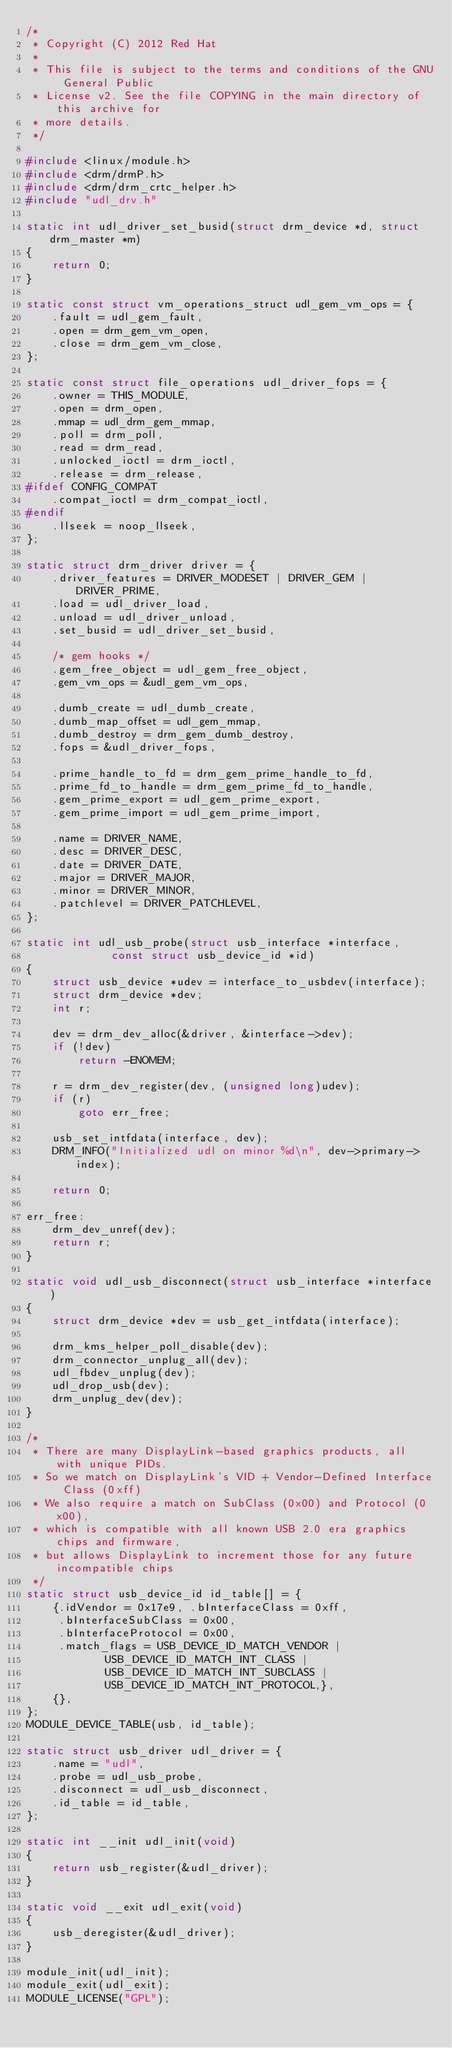<code> <loc_0><loc_0><loc_500><loc_500><_C_>/*
 * Copyright (C) 2012 Red Hat
 *
 * This file is subject to the terms and conditions of the GNU General Public
 * License v2. See the file COPYING in the main directory of this archive for
 * more details.
 */

#include <linux/module.h>
#include <drm/drmP.h>
#include <drm/drm_crtc_helper.h>
#include "udl_drv.h"

static int udl_driver_set_busid(struct drm_device *d, struct drm_master *m)
{
	return 0;
}

static const struct vm_operations_struct udl_gem_vm_ops = {
	.fault = udl_gem_fault,
	.open = drm_gem_vm_open,
	.close = drm_gem_vm_close,
};

static const struct file_operations udl_driver_fops = {
	.owner = THIS_MODULE,
	.open = drm_open,
	.mmap = udl_drm_gem_mmap,
	.poll = drm_poll,
	.read = drm_read,
	.unlocked_ioctl	= drm_ioctl,
	.release = drm_release,
#ifdef CONFIG_COMPAT
	.compat_ioctl = drm_compat_ioctl,
#endif
	.llseek = noop_llseek,
};

static struct drm_driver driver = {
	.driver_features = DRIVER_MODESET | DRIVER_GEM | DRIVER_PRIME,
	.load = udl_driver_load,
	.unload = udl_driver_unload,
	.set_busid = udl_driver_set_busid,

	/* gem hooks */
	.gem_free_object = udl_gem_free_object,
	.gem_vm_ops = &udl_gem_vm_ops,

	.dumb_create = udl_dumb_create,
	.dumb_map_offset = udl_gem_mmap,
	.dumb_destroy = drm_gem_dumb_destroy,
	.fops = &udl_driver_fops,

	.prime_handle_to_fd = drm_gem_prime_handle_to_fd,
	.prime_fd_to_handle = drm_gem_prime_fd_to_handle,
	.gem_prime_export = udl_gem_prime_export,
	.gem_prime_import = udl_gem_prime_import,

	.name = DRIVER_NAME,
	.desc = DRIVER_DESC,
	.date = DRIVER_DATE,
	.major = DRIVER_MAJOR,
	.minor = DRIVER_MINOR,
	.patchlevel = DRIVER_PATCHLEVEL,
};

static int udl_usb_probe(struct usb_interface *interface,
			 const struct usb_device_id *id)
{
	struct usb_device *udev = interface_to_usbdev(interface);
	struct drm_device *dev;
	int r;

	dev = drm_dev_alloc(&driver, &interface->dev);
	if (!dev)
		return -ENOMEM;

	r = drm_dev_register(dev, (unsigned long)udev);
	if (r)
		goto err_free;

	usb_set_intfdata(interface, dev);
	DRM_INFO("Initialized udl on minor %d\n", dev->primary->index);

	return 0;

err_free:
	drm_dev_unref(dev);
	return r;
}

static void udl_usb_disconnect(struct usb_interface *interface)
{
	struct drm_device *dev = usb_get_intfdata(interface);

	drm_kms_helper_poll_disable(dev);
	drm_connector_unplug_all(dev);
	udl_fbdev_unplug(dev);
	udl_drop_usb(dev);
	drm_unplug_dev(dev);
}

/*
 * There are many DisplayLink-based graphics products, all with unique PIDs.
 * So we match on DisplayLink's VID + Vendor-Defined Interface Class (0xff)
 * We also require a match on SubClass (0x00) and Protocol (0x00),
 * which is compatible with all known USB 2.0 era graphics chips and firmware,
 * but allows DisplayLink to increment those for any future incompatible chips
 */
static struct usb_device_id id_table[] = {
	{.idVendor = 0x17e9, .bInterfaceClass = 0xff,
	 .bInterfaceSubClass = 0x00,
	 .bInterfaceProtocol = 0x00,
	 .match_flags = USB_DEVICE_ID_MATCH_VENDOR |
			USB_DEVICE_ID_MATCH_INT_CLASS |
			USB_DEVICE_ID_MATCH_INT_SUBCLASS |
			USB_DEVICE_ID_MATCH_INT_PROTOCOL,},
	{},
};
MODULE_DEVICE_TABLE(usb, id_table);

static struct usb_driver udl_driver = {
	.name = "udl",
	.probe = udl_usb_probe,
	.disconnect = udl_usb_disconnect,
	.id_table = id_table,
};

static int __init udl_init(void)
{
	return usb_register(&udl_driver);
}

static void __exit udl_exit(void)
{
	usb_deregister(&udl_driver);
}

module_init(udl_init);
module_exit(udl_exit);
MODULE_LICENSE("GPL");
</code> 